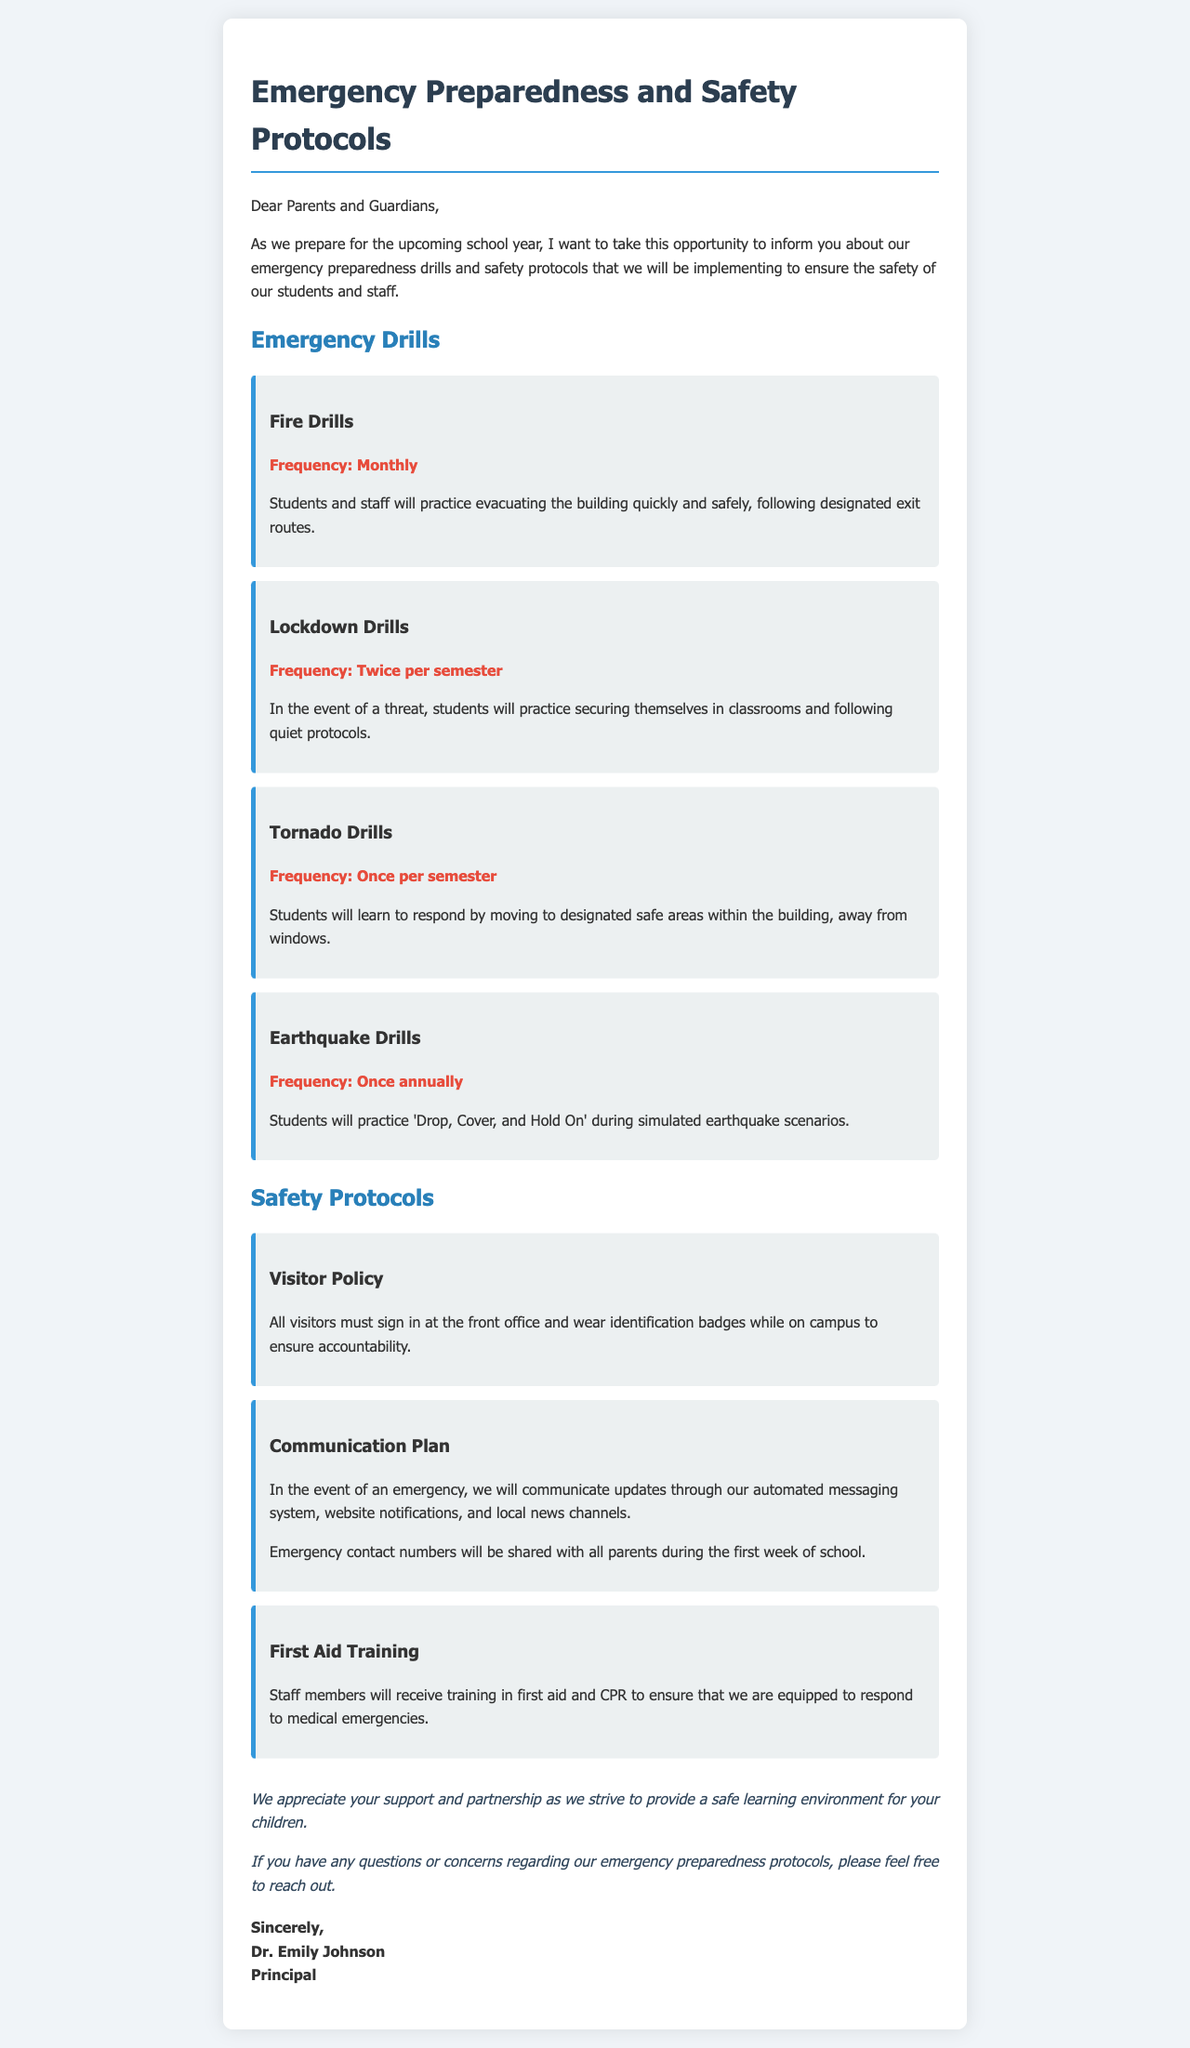what is the title of the letter? The title is the heading that summarizes the main topic of the letter.
Answer: Emergency Preparedness and Safety Protocols who is the principal signing the letter? The principal's name is stated at the end of the letter as part of the signature.
Answer: Dr. Emily Johnson how often are fire drills conducted? The frequency of fire drills is specified under the emergency drills section.
Answer: Monthly how many lockdown drills are performed each semester? The document explicitly states the number of lockdown drills that will take place each semester.
Answer: Twice per semester what is required of all visitors on campus? The document outlines a specific policy regarding visitors in the school.
Answer: Sign in at the front office and wear identification badges what is the emergency communication plan? The plan describes how updates will be communicated during emergencies, which is summarized in the document.
Answer: Automated messaging system, website notifications, and local news channels how frequently are earthquake drills practiced? This information is provided in the emergency drills section regarding the frequency of the drills.
Answer: Once annually what training will staff members receive? The document mentions the type of training staff will undergo to manage medical emergencies.
Answer: First aid and CPR what is the purpose of the letter? The purpose is to inform parents and guardians about safety measures and preparedness for the upcoming school year.
Answer: To inform about emergency preparedness drills and safety protocols 